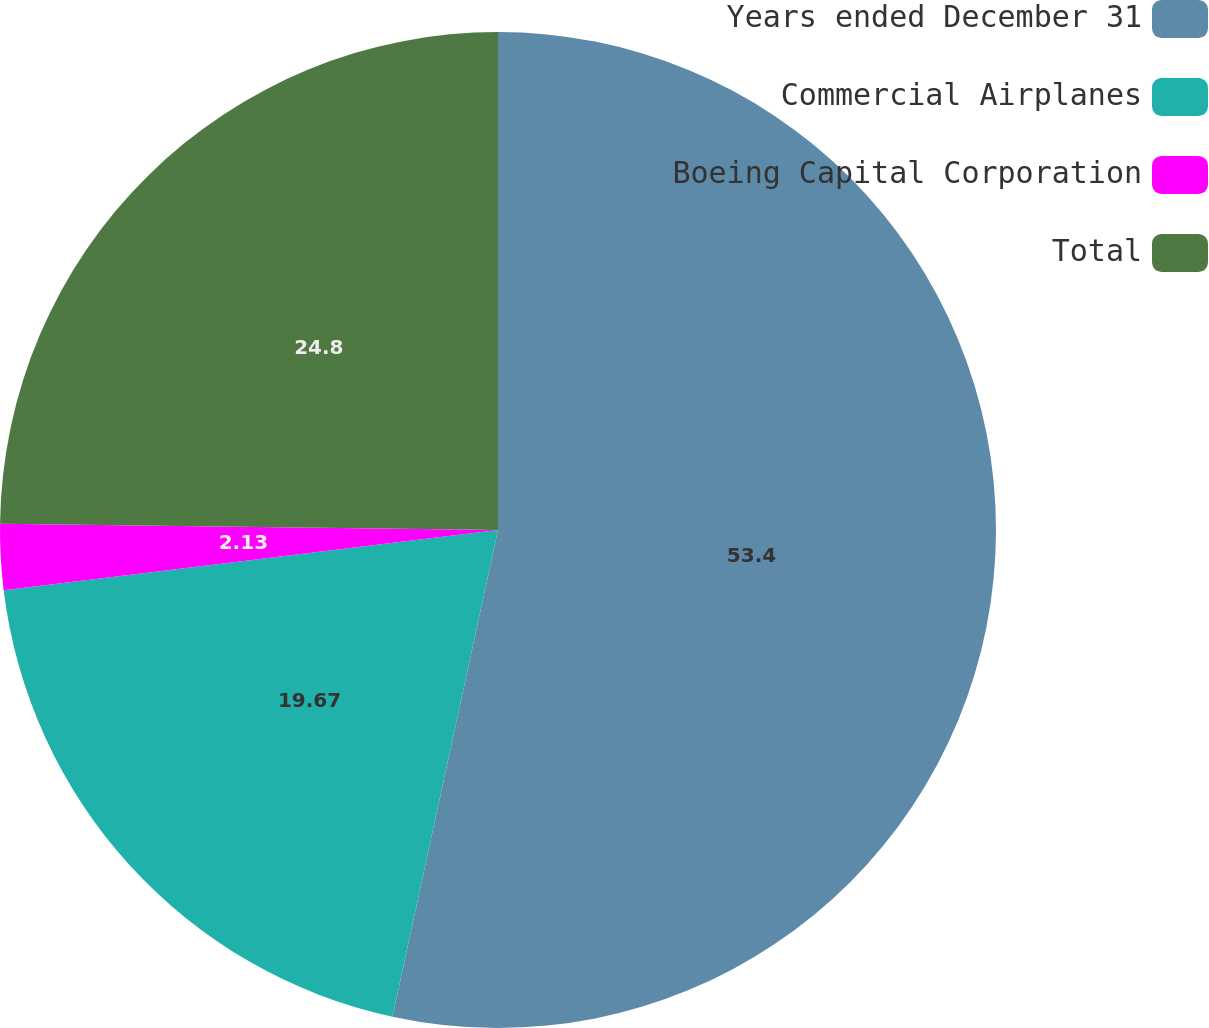Convert chart. <chart><loc_0><loc_0><loc_500><loc_500><pie_chart><fcel>Years ended December 31<fcel>Commercial Airplanes<fcel>Boeing Capital Corporation<fcel>Total<nl><fcel>53.4%<fcel>19.67%<fcel>2.13%<fcel>24.8%<nl></chart> 